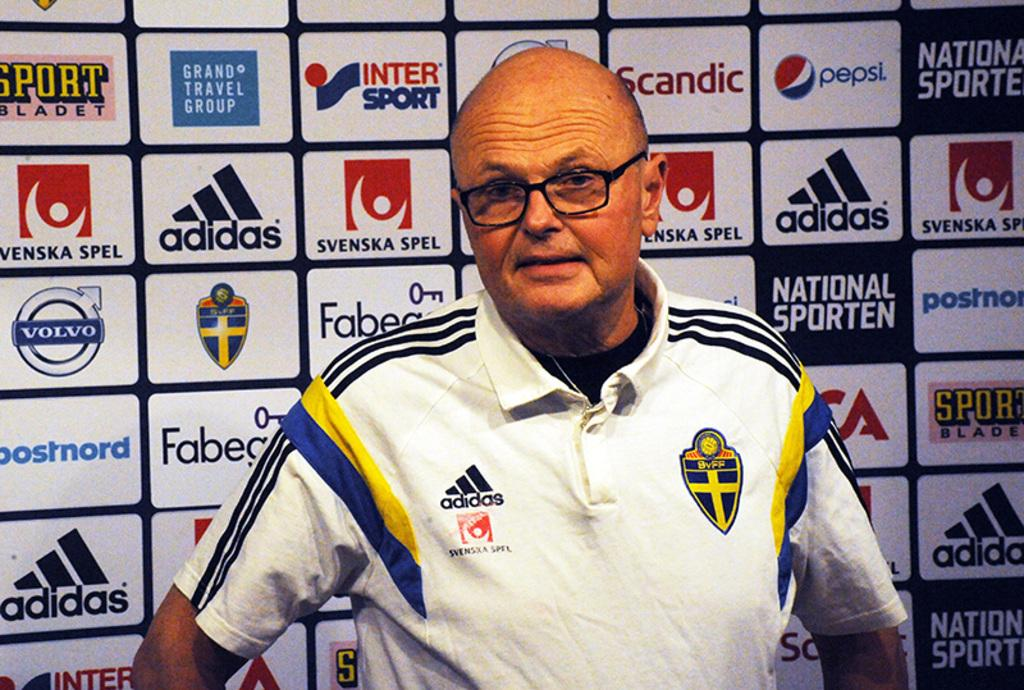Who or what is present in the image? There is a person in the image. Can you describe the person's appearance? The person is wearing glasses (specs). What can be seen in the background of the image? There is a wall with logos of different brands in the background of the image. Can you tell me how many rabbits are sitting on the person's lap in the image? There are no rabbits present in the image; it features a person wearing glasses and a background with logos of different brands. 